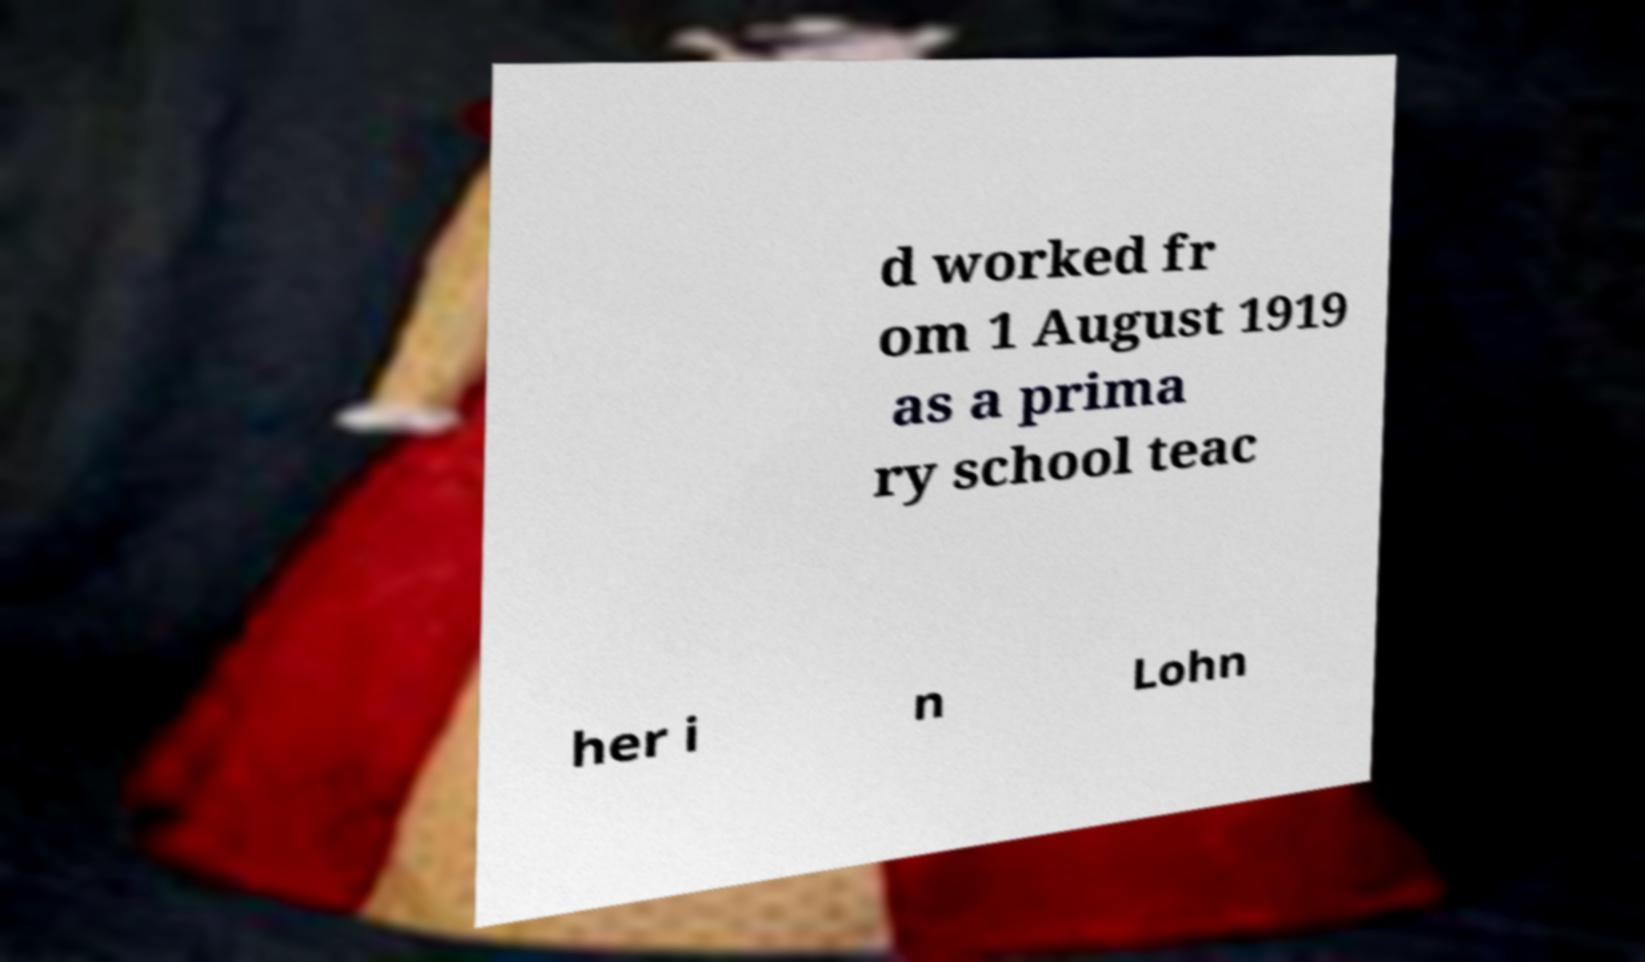Could you assist in decoding the text presented in this image and type it out clearly? d worked fr om 1 August 1919 as a prima ry school teac her i n Lohn 